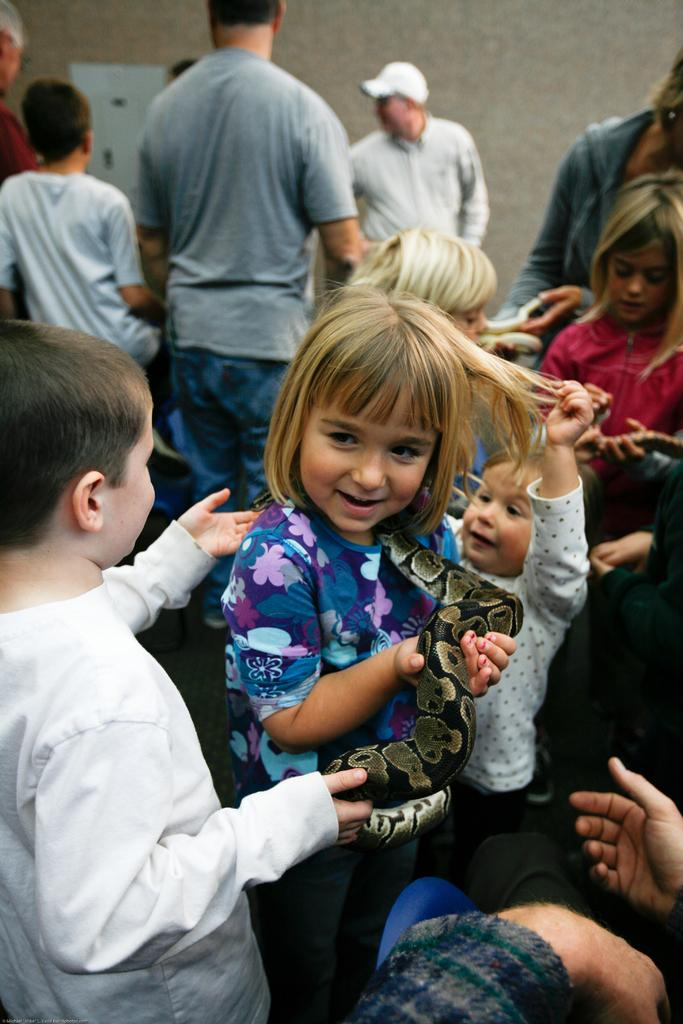What is happening in the image? There is a group of persons in the image, and they are playing. Can you describe the people in the background of the image? There are persons standing in the background of the image. What invention is being demonstrated by the crowd in the image? There is no crowd present in the image, and no invention is being demonstrated. 